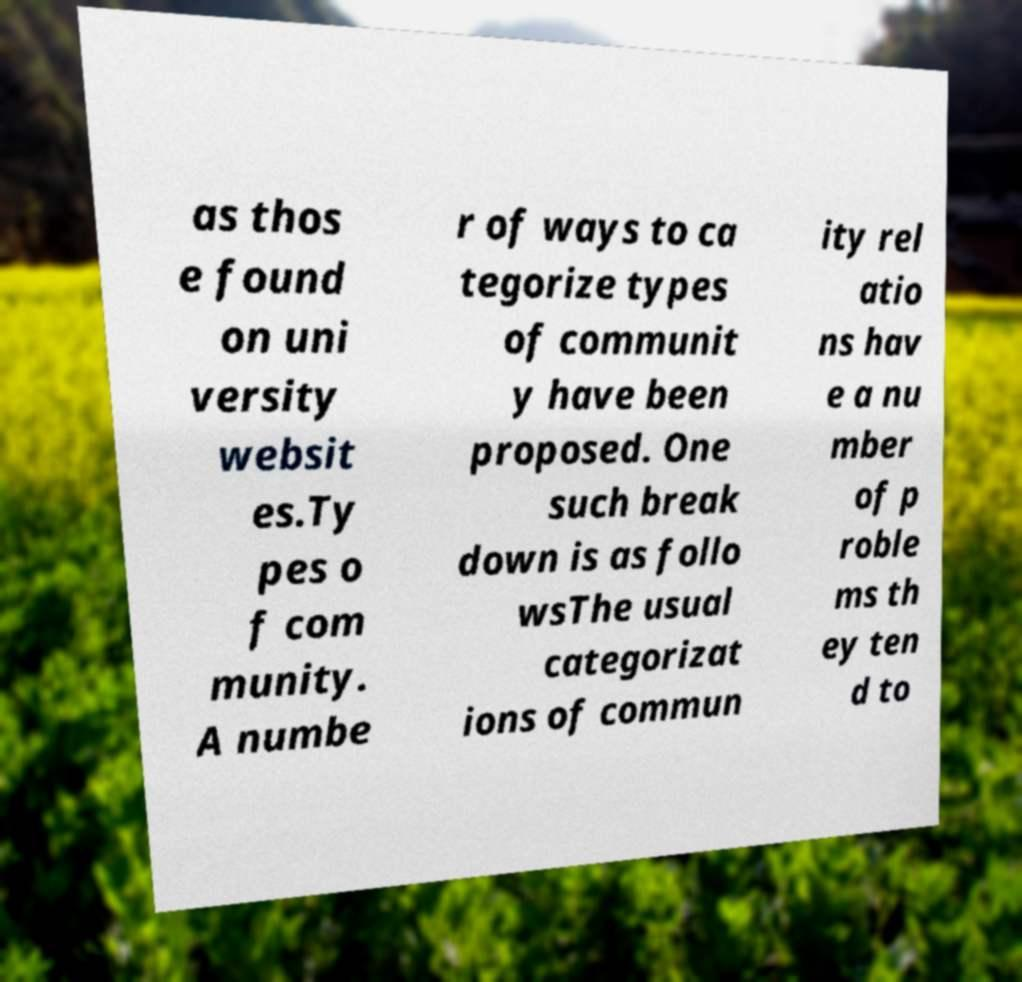Can you accurately transcribe the text from the provided image for me? as thos e found on uni versity websit es.Ty pes o f com munity. A numbe r of ways to ca tegorize types of communit y have been proposed. One such break down is as follo wsThe usual categorizat ions of commun ity rel atio ns hav e a nu mber of p roble ms th ey ten d to 